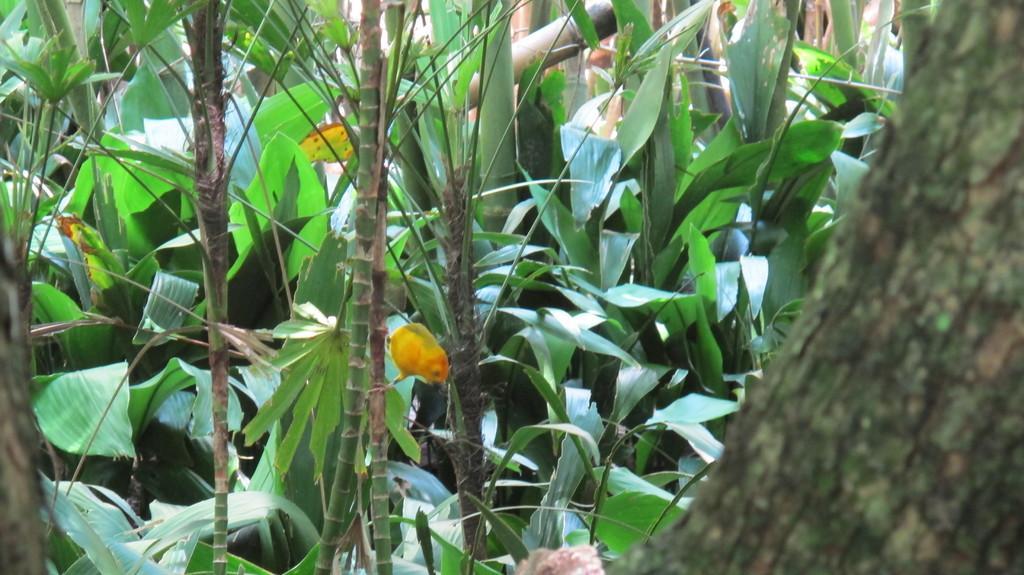Can you describe this image briefly? In the image we can see some trees. 